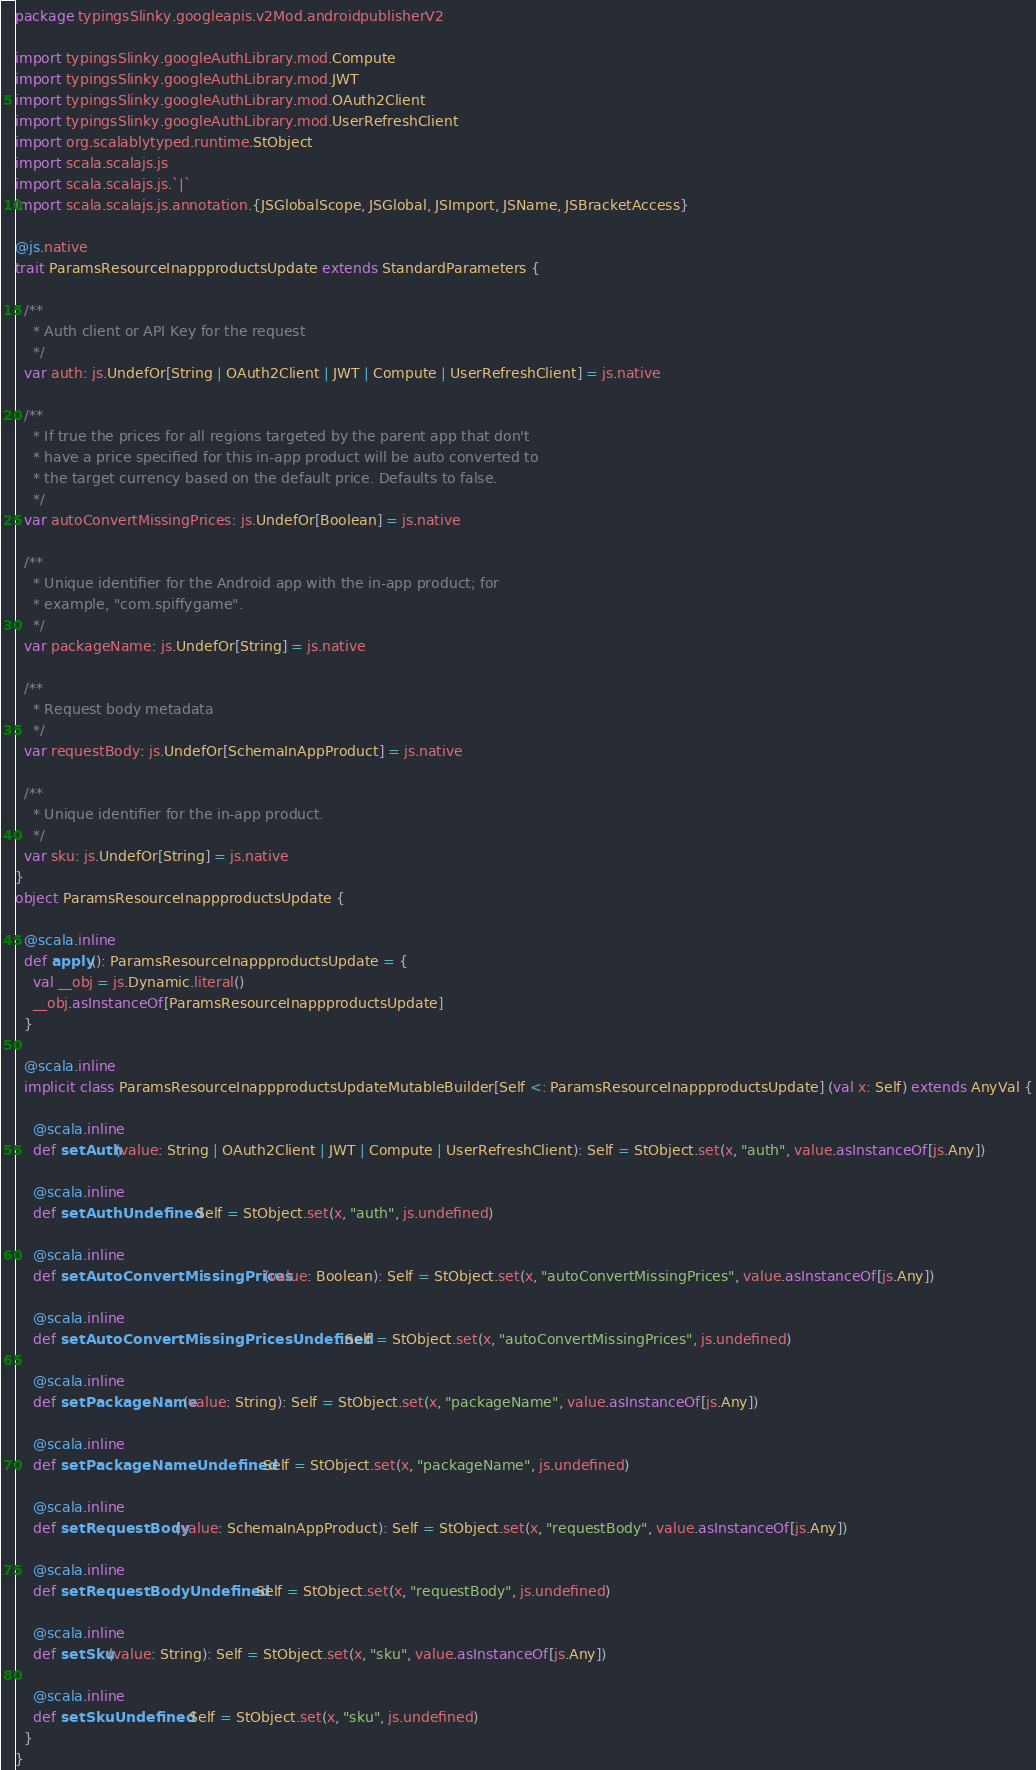<code> <loc_0><loc_0><loc_500><loc_500><_Scala_>package typingsSlinky.googleapis.v2Mod.androidpublisherV2

import typingsSlinky.googleAuthLibrary.mod.Compute
import typingsSlinky.googleAuthLibrary.mod.JWT
import typingsSlinky.googleAuthLibrary.mod.OAuth2Client
import typingsSlinky.googleAuthLibrary.mod.UserRefreshClient
import org.scalablytyped.runtime.StObject
import scala.scalajs.js
import scala.scalajs.js.`|`
import scala.scalajs.js.annotation.{JSGlobalScope, JSGlobal, JSImport, JSName, JSBracketAccess}

@js.native
trait ParamsResourceInappproductsUpdate extends StandardParameters {
  
  /**
    * Auth client or API Key for the request
    */
  var auth: js.UndefOr[String | OAuth2Client | JWT | Compute | UserRefreshClient] = js.native
  
  /**
    * If true the prices for all regions targeted by the parent app that don't
    * have a price specified for this in-app product will be auto converted to
    * the target currency based on the default price. Defaults to false.
    */
  var autoConvertMissingPrices: js.UndefOr[Boolean] = js.native
  
  /**
    * Unique identifier for the Android app with the in-app product; for
    * example, "com.spiffygame".
    */
  var packageName: js.UndefOr[String] = js.native
  
  /**
    * Request body metadata
    */
  var requestBody: js.UndefOr[SchemaInAppProduct] = js.native
  
  /**
    * Unique identifier for the in-app product.
    */
  var sku: js.UndefOr[String] = js.native
}
object ParamsResourceInappproductsUpdate {
  
  @scala.inline
  def apply(): ParamsResourceInappproductsUpdate = {
    val __obj = js.Dynamic.literal()
    __obj.asInstanceOf[ParamsResourceInappproductsUpdate]
  }
  
  @scala.inline
  implicit class ParamsResourceInappproductsUpdateMutableBuilder[Self <: ParamsResourceInappproductsUpdate] (val x: Self) extends AnyVal {
    
    @scala.inline
    def setAuth(value: String | OAuth2Client | JWT | Compute | UserRefreshClient): Self = StObject.set(x, "auth", value.asInstanceOf[js.Any])
    
    @scala.inline
    def setAuthUndefined: Self = StObject.set(x, "auth", js.undefined)
    
    @scala.inline
    def setAutoConvertMissingPrices(value: Boolean): Self = StObject.set(x, "autoConvertMissingPrices", value.asInstanceOf[js.Any])
    
    @scala.inline
    def setAutoConvertMissingPricesUndefined: Self = StObject.set(x, "autoConvertMissingPrices", js.undefined)
    
    @scala.inline
    def setPackageName(value: String): Self = StObject.set(x, "packageName", value.asInstanceOf[js.Any])
    
    @scala.inline
    def setPackageNameUndefined: Self = StObject.set(x, "packageName", js.undefined)
    
    @scala.inline
    def setRequestBody(value: SchemaInAppProduct): Self = StObject.set(x, "requestBody", value.asInstanceOf[js.Any])
    
    @scala.inline
    def setRequestBodyUndefined: Self = StObject.set(x, "requestBody", js.undefined)
    
    @scala.inline
    def setSku(value: String): Self = StObject.set(x, "sku", value.asInstanceOf[js.Any])
    
    @scala.inline
    def setSkuUndefined: Self = StObject.set(x, "sku", js.undefined)
  }
}
</code> 